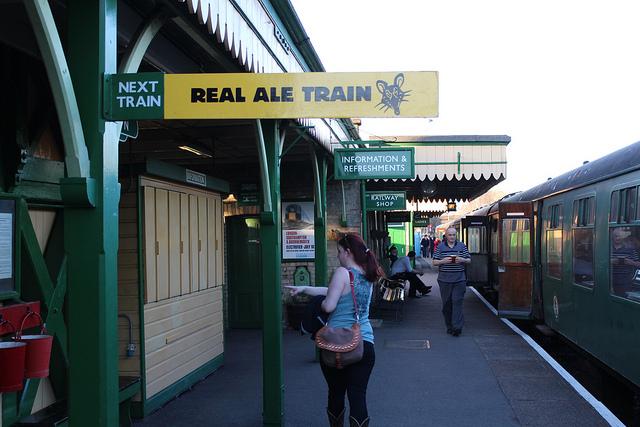Is this picture in full color?
Be succinct. Yes. Is the train moving?
Give a very brief answer. No. What platform number is this?
Keep it brief. 2. Are there people on the platform?
Write a very short answer. Yes. What is the women pointing at?
Answer briefly. Lockers. Are the train doors open?
Write a very short answer. Yes. What country is this train station in?
Give a very brief answer. Usa. 